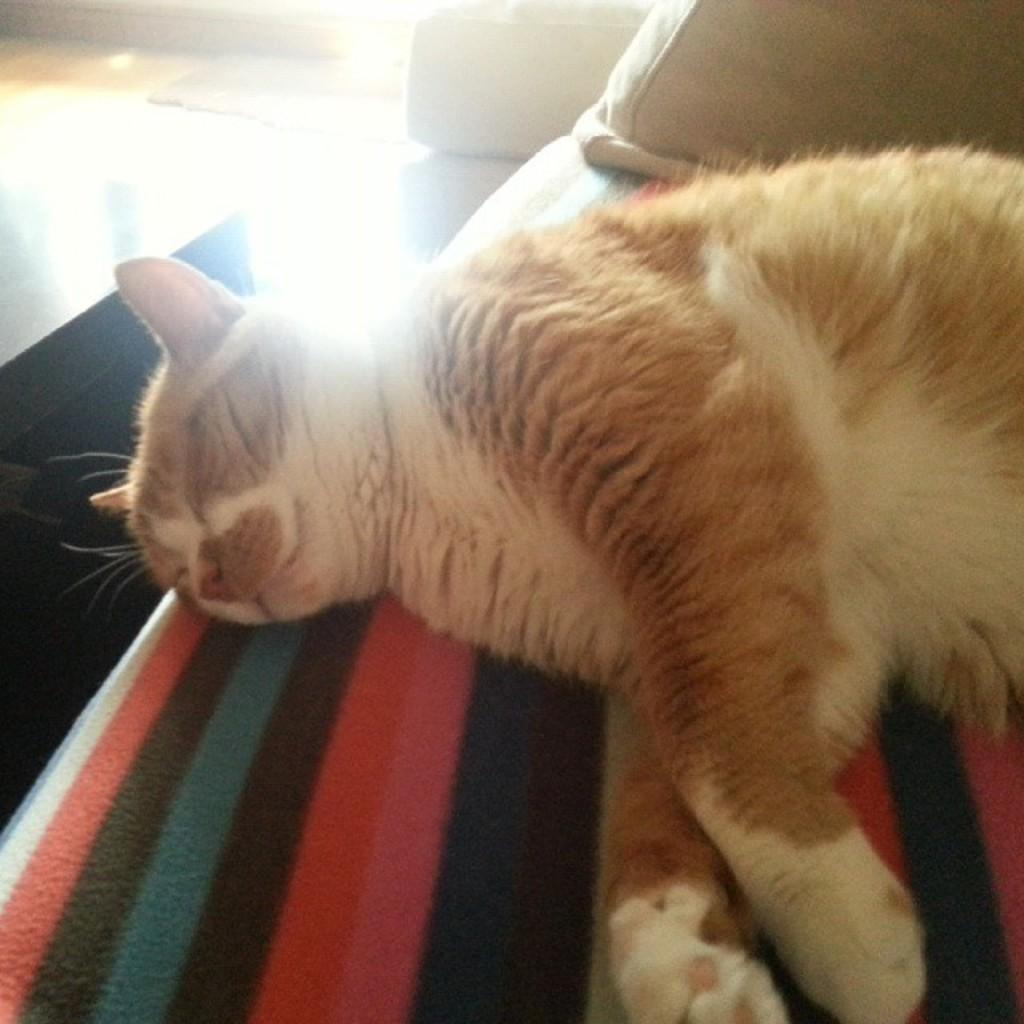What type of animal can be seen in the image? There is a cat in the image. What is the cat doing in the image? The cat is sleeping on a couch. What is located at the top of the image? There is a cushion at the top of the image. What piece of furniture is present in the image? There is a table in the image. Can you see any ocean waves in the image? There is no ocean or waves present in the image; it features a cat sleeping on a couch. 